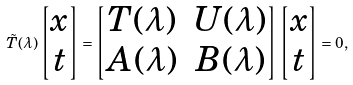<formula> <loc_0><loc_0><loc_500><loc_500>\tilde { T } ( \lambda ) \begin{bmatrix} x \\ t \end{bmatrix} = \begin{bmatrix} T ( \lambda ) & U ( \lambda ) \\ A ( \lambda ) & B ( \lambda ) \end{bmatrix} \begin{bmatrix} x \\ t \end{bmatrix} = 0 ,</formula> 